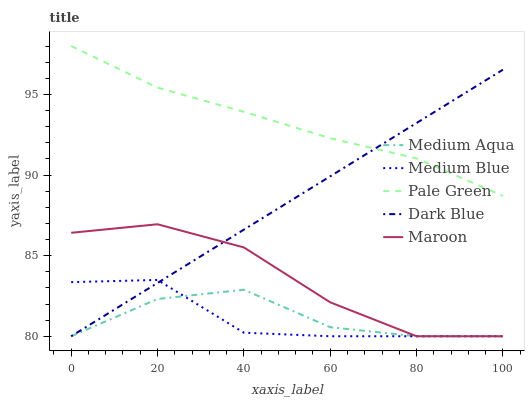Does Medium Blue have the minimum area under the curve?
Answer yes or no. Yes. Does Pale Green have the maximum area under the curve?
Answer yes or no. Yes. Does Medium Aqua have the minimum area under the curve?
Answer yes or no. No. Does Medium Aqua have the maximum area under the curve?
Answer yes or no. No. Is Dark Blue the smoothest?
Answer yes or no. Yes. Is Maroon the roughest?
Answer yes or no. Yes. Is Pale Green the smoothest?
Answer yes or no. No. Is Pale Green the roughest?
Answer yes or no. No. Does Pale Green have the lowest value?
Answer yes or no. No. Does Pale Green have the highest value?
Answer yes or no. Yes. Does Medium Aqua have the highest value?
Answer yes or no. No. Is Medium Blue less than Pale Green?
Answer yes or no. Yes. Is Pale Green greater than Medium Aqua?
Answer yes or no. Yes. Does Medium Blue intersect Medium Aqua?
Answer yes or no. Yes. Is Medium Blue less than Medium Aqua?
Answer yes or no. No. Is Medium Blue greater than Medium Aqua?
Answer yes or no. No. Does Medium Blue intersect Pale Green?
Answer yes or no. No. 